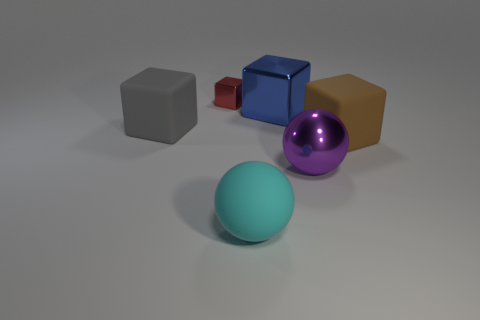Add 3 large purple metallic things. How many objects exist? 9 Subtract all brown matte cubes. How many cubes are left? 3 Subtract all blocks. How many objects are left? 2 Subtract 1 spheres. How many spheres are left? 1 Subtract all yellow spheres. Subtract all brown cylinders. How many spheres are left? 2 Subtract all purple cylinders. How many green balls are left? 0 Subtract all tiny red objects. Subtract all large purple shiny spheres. How many objects are left? 4 Add 1 blue blocks. How many blue blocks are left? 2 Add 1 cyan shiny objects. How many cyan shiny objects exist? 1 Subtract all brown blocks. How many blocks are left? 3 